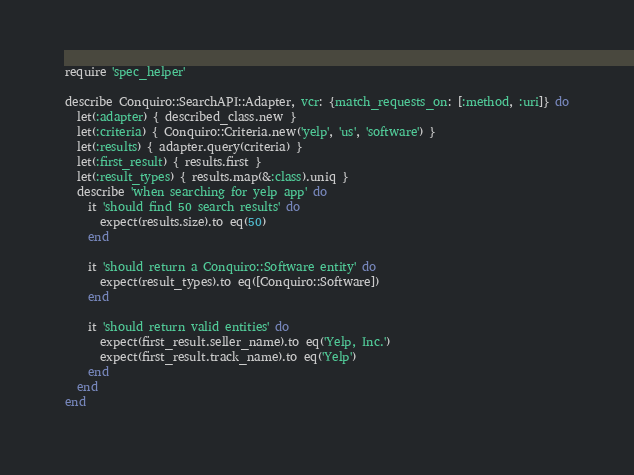<code> <loc_0><loc_0><loc_500><loc_500><_Ruby_>require 'spec_helper'

describe Conquiro::SearchAPI::Adapter, vcr: {match_requests_on: [:method, :uri]} do
  let(:adapter) { described_class.new }
  let(:criteria) { Conquiro::Criteria.new('yelp', 'us', 'software') }
  let(:results) { adapter.query(criteria) }
  let(:first_result) { results.first }
  let(:result_types) { results.map(&:class).uniq }
  describe 'when searching for yelp app' do
    it 'should find 50 search results' do
      expect(results.size).to eq(50)
    end

    it 'should return a Conquiro::Software entity' do
      expect(result_types).to eq([Conquiro::Software])
    end

    it 'should return valid entities' do
      expect(first_result.seller_name).to eq('Yelp, Inc.')
      expect(first_result.track_name).to eq('Yelp')
    end
  end
end
</code> 